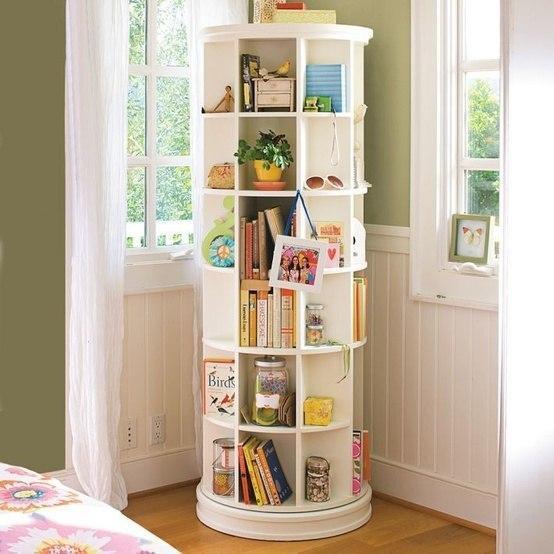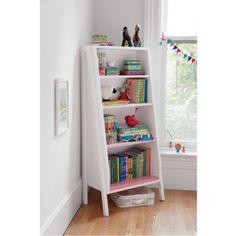The first image is the image on the left, the second image is the image on the right. Assess this claim about the two images: "In the image on the left, the shelves are placed in a corner.". Correct or not? Answer yes or no. Yes. The first image is the image on the left, the second image is the image on the right. Evaluate the accuracy of this statement regarding the images: "One image shows a shelf unit with open back and sides that resembles a ladder leaning on a wall, and it is not positioned in a corner.". Is it true? Answer yes or no. No. 